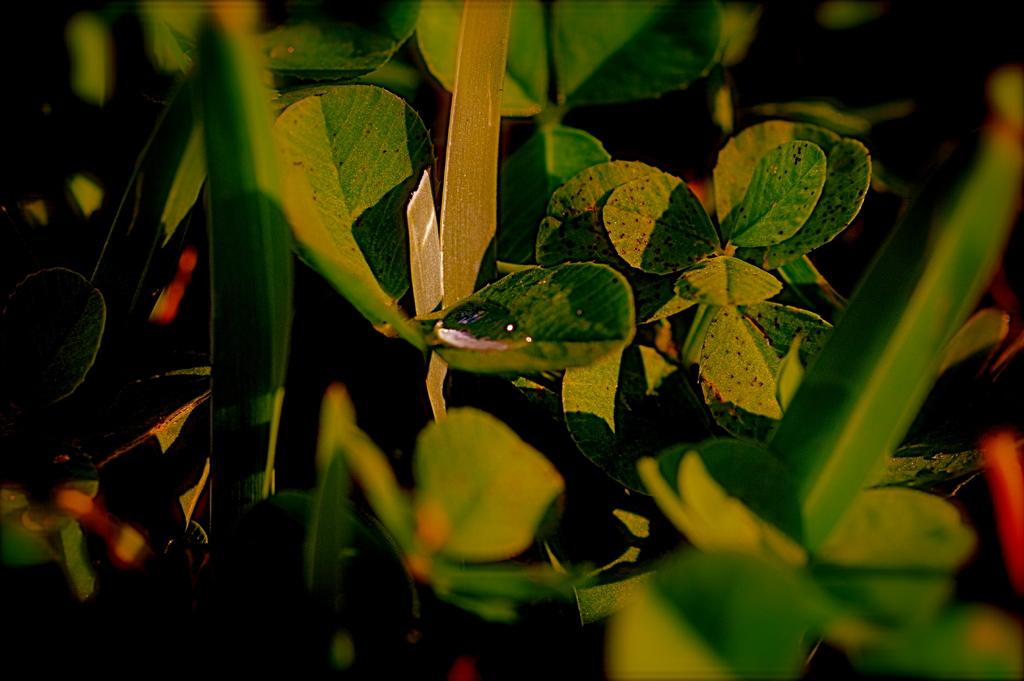What type of living organisms can be seen in the image? Plants can be seen in the image. Can you describe a specific detail about one of the plants? Yes, there is a water drop on a leaf in the image. Is there an umbrella visible in the image to protect the plants from the rain? There is no mention of rain or an umbrella in the image; it only shows plants and a water drop on a leaf. 